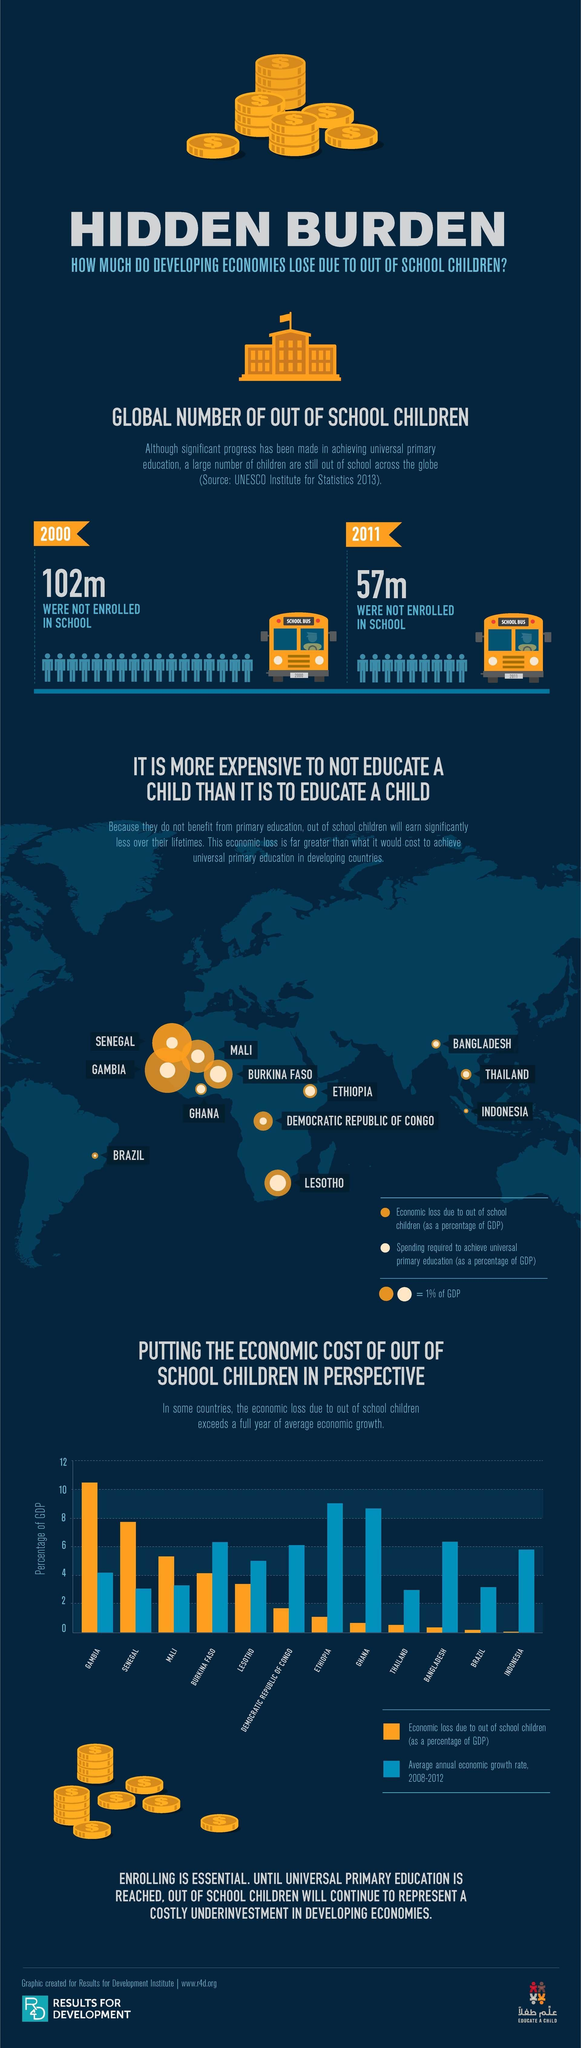How many children were not enrolled in the school in 2011?
Answer the question with a short phrase. 57m How many children were not enrolled in the school in 2000? 102m 